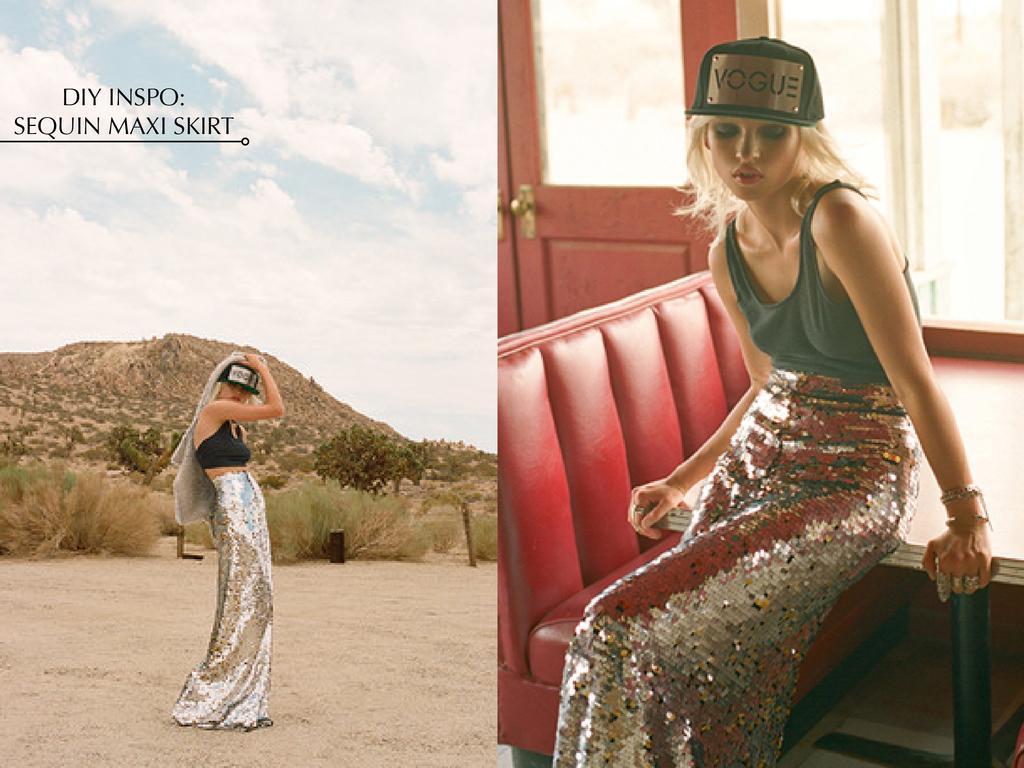Can you describe this image briefly? Here this picture is a collage image, in which we can see a woman sitting on a table in right side with a cap on her and the same woman standing on the ground on the left side and we can see plants and trees present all over there behind her and we can see mountains covered with grass over there and we can also see clouds in the sky. 